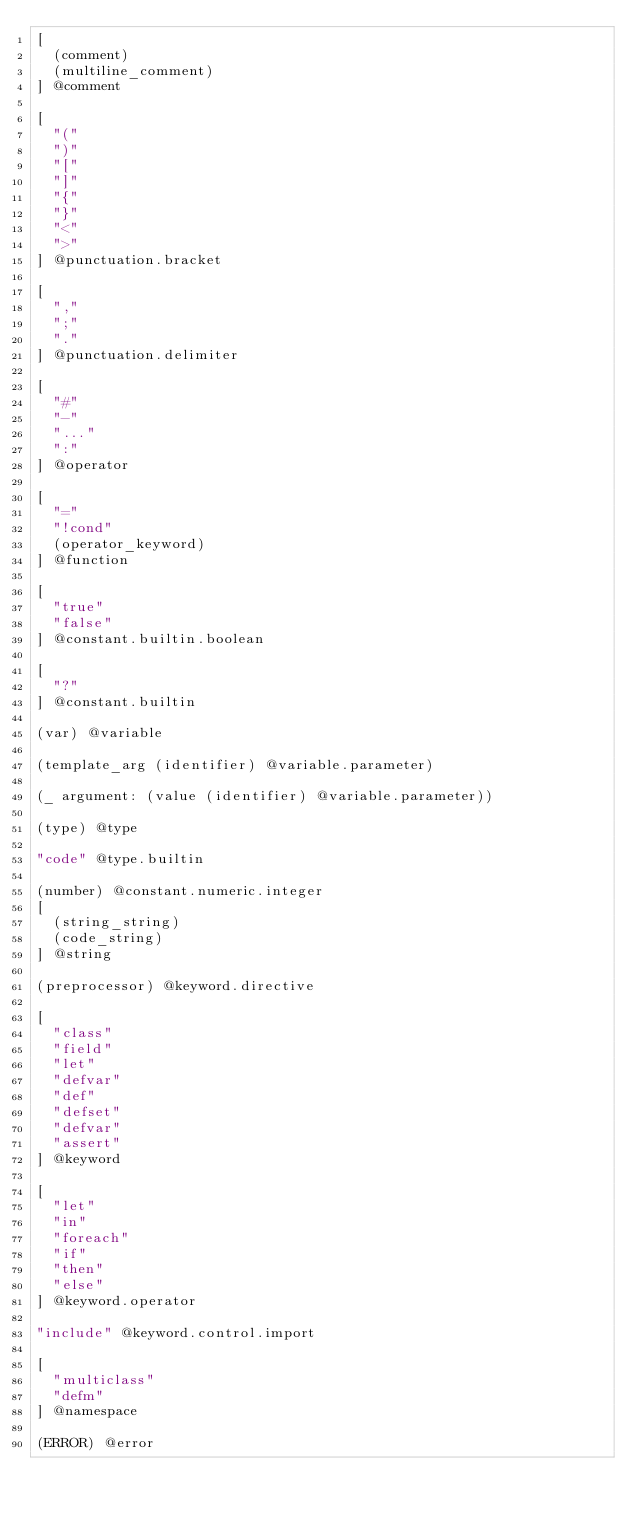<code> <loc_0><loc_0><loc_500><loc_500><_Scheme_>[
  (comment)
  (multiline_comment)
] @comment

[
  "("
  ")"
  "["
  "]"
  "{"
  "}"
  "<"
  ">"
] @punctuation.bracket

[
  ","
  ";"
  "."
] @punctuation.delimiter

[
  "#"
  "-"
  "..."
  ":"
] @operator

[
  "="
  "!cond"
  (operator_keyword)
] @function

[
  "true"
  "false"
] @constant.builtin.boolean

[
  "?"
] @constant.builtin

(var) @variable

(template_arg (identifier) @variable.parameter)

(_ argument: (value (identifier) @variable.parameter))

(type) @type

"code" @type.builtin

(number) @constant.numeric.integer
[
  (string_string)
  (code_string)
] @string

(preprocessor) @keyword.directive

[
  "class"
  "field"
  "let"
  "defvar"
  "def"
  "defset"
  "defvar"
  "assert"
] @keyword

[
  "let"
  "in"
  "foreach"
  "if"
  "then"
  "else"
] @keyword.operator

"include" @keyword.control.import

[
  "multiclass"
  "defm"
] @namespace

(ERROR) @error
</code> 